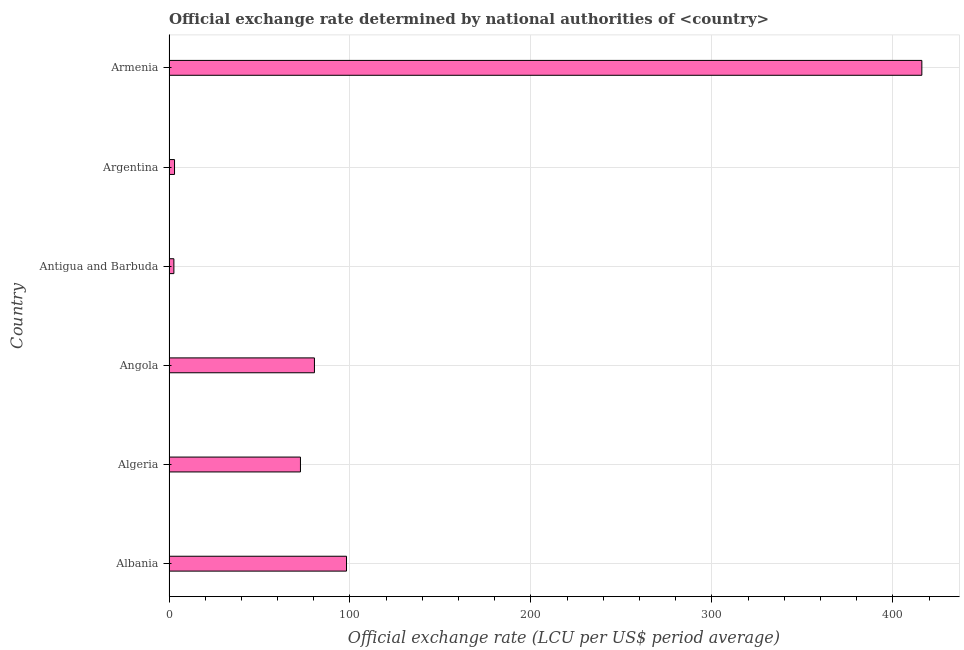Does the graph contain any zero values?
Ensure brevity in your answer.  No. Does the graph contain grids?
Your response must be concise. Yes. What is the title of the graph?
Make the answer very short. Official exchange rate determined by national authorities of <country>. What is the label or title of the X-axis?
Provide a short and direct response. Official exchange rate (LCU per US$ period average). What is the label or title of the Y-axis?
Provide a succinct answer. Country. What is the official exchange rate in Angola?
Your answer should be very brief. 80.37. Across all countries, what is the maximum official exchange rate?
Give a very brief answer. 416.04. Across all countries, what is the minimum official exchange rate?
Keep it short and to the point. 2.7. In which country was the official exchange rate maximum?
Your answer should be compact. Armenia. In which country was the official exchange rate minimum?
Make the answer very short. Antigua and Barbuda. What is the sum of the official exchange rate?
Your answer should be compact. 672.91. What is the difference between the official exchange rate in Albania and Algeria?
Give a very brief answer. 25.46. What is the average official exchange rate per country?
Your response must be concise. 112.15. What is the median official exchange rate?
Offer a terse response. 76.51. What is the ratio of the official exchange rate in Algeria to that in Angola?
Make the answer very short. 0.9. Is the official exchange rate in Algeria less than that in Antigua and Barbuda?
Give a very brief answer. No. What is the difference between the highest and the second highest official exchange rate?
Offer a terse response. 317.94. Is the sum of the official exchange rate in Antigua and Barbuda and Argentina greater than the maximum official exchange rate across all countries?
Provide a short and direct response. No. What is the difference between the highest and the lowest official exchange rate?
Make the answer very short. 413.34. In how many countries, is the official exchange rate greater than the average official exchange rate taken over all countries?
Your response must be concise. 1. How many bars are there?
Offer a terse response. 6. How many countries are there in the graph?
Give a very brief answer. 6. What is the Official exchange rate (LCU per US$ period average) of Albania?
Your answer should be compact. 98.1. What is the Official exchange rate (LCU per US$ period average) in Algeria?
Your response must be concise. 72.65. What is the Official exchange rate (LCU per US$ period average) in Angola?
Ensure brevity in your answer.  80.37. What is the Official exchange rate (LCU per US$ period average) of Argentina?
Offer a very short reply. 3.05. What is the Official exchange rate (LCU per US$ period average) in Armenia?
Offer a terse response. 416.04. What is the difference between the Official exchange rate (LCU per US$ period average) in Albania and Algeria?
Make the answer very short. 25.46. What is the difference between the Official exchange rate (LCU per US$ period average) in Albania and Angola?
Keep it short and to the point. 17.74. What is the difference between the Official exchange rate (LCU per US$ period average) in Albania and Antigua and Barbuda?
Ensure brevity in your answer.  95.4. What is the difference between the Official exchange rate (LCU per US$ period average) in Albania and Argentina?
Your answer should be compact. 95.05. What is the difference between the Official exchange rate (LCU per US$ period average) in Albania and Armenia?
Give a very brief answer. -317.94. What is the difference between the Official exchange rate (LCU per US$ period average) in Algeria and Angola?
Ensure brevity in your answer.  -7.72. What is the difference between the Official exchange rate (LCU per US$ period average) in Algeria and Antigua and Barbuda?
Provide a short and direct response. 69.95. What is the difference between the Official exchange rate (LCU per US$ period average) in Algeria and Argentina?
Your response must be concise. 69.59. What is the difference between the Official exchange rate (LCU per US$ period average) in Algeria and Armenia?
Your response must be concise. -343.39. What is the difference between the Official exchange rate (LCU per US$ period average) in Angola and Antigua and Barbuda?
Your response must be concise. 77.67. What is the difference between the Official exchange rate (LCU per US$ period average) in Angola and Argentina?
Keep it short and to the point. 77.31. What is the difference between the Official exchange rate (LCU per US$ period average) in Angola and Armenia?
Give a very brief answer. -335.67. What is the difference between the Official exchange rate (LCU per US$ period average) in Antigua and Barbuda and Argentina?
Your response must be concise. -0.35. What is the difference between the Official exchange rate (LCU per US$ period average) in Antigua and Barbuda and Armenia?
Make the answer very short. -413.34. What is the difference between the Official exchange rate (LCU per US$ period average) in Argentina and Armenia?
Your answer should be very brief. -412.99. What is the ratio of the Official exchange rate (LCU per US$ period average) in Albania to that in Algeria?
Give a very brief answer. 1.35. What is the ratio of the Official exchange rate (LCU per US$ period average) in Albania to that in Angola?
Provide a succinct answer. 1.22. What is the ratio of the Official exchange rate (LCU per US$ period average) in Albania to that in Antigua and Barbuda?
Provide a succinct answer. 36.34. What is the ratio of the Official exchange rate (LCU per US$ period average) in Albania to that in Argentina?
Provide a short and direct response. 32.12. What is the ratio of the Official exchange rate (LCU per US$ period average) in Albania to that in Armenia?
Offer a very short reply. 0.24. What is the ratio of the Official exchange rate (LCU per US$ period average) in Algeria to that in Angola?
Provide a short and direct response. 0.9. What is the ratio of the Official exchange rate (LCU per US$ period average) in Algeria to that in Antigua and Barbuda?
Provide a short and direct response. 26.91. What is the ratio of the Official exchange rate (LCU per US$ period average) in Algeria to that in Argentina?
Provide a short and direct response. 23.79. What is the ratio of the Official exchange rate (LCU per US$ period average) in Algeria to that in Armenia?
Provide a short and direct response. 0.17. What is the ratio of the Official exchange rate (LCU per US$ period average) in Angola to that in Antigua and Barbuda?
Provide a short and direct response. 29.77. What is the ratio of the Official exchange rate (LCU per US$ period average) in Angola to that in Argentina?
Give a very brief answer. 26.31. What is the ratio of the Official exchange rate (LCU per US$ period average) in Angola to that in Armenia?
Your response must be concise. 0.19. What is the ratio of the Official exchange rate (LCU per US$ period average) in Antigua and Barbuda to that in Argentina?
Give a very brief answer. 0.88. What is the ratio of the Official exchange rate (LCU per US$ period average) in Antigua and Barbuda to that in Armenia?
Your response must be concise. 0.01. What is the ratio of the Official exchange rate (LCU per US$ period average) in Argentina to that in Armenia?
Make the answer very short. 0.01. 